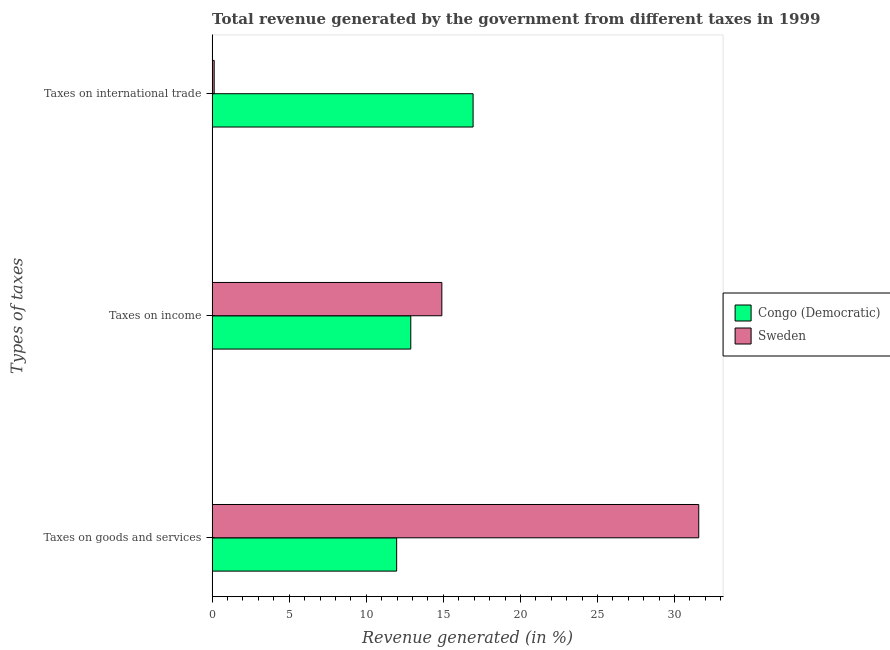How many groups of bars are there?
Provide a short and direct response. 3. Are the number of bars per tick equal to the number of legend labels?
Your answer should be compact. Yes. Are the number of bars on each tick of the Y-axis equal?
Provide a short and direct response. Yes. What is the label of the 3rd group of bars from the top?
Provide a short and direct response. Taxes on goods and services. What is the percentage of revenue generated by taxes on goods and services in Sweden?
Keep it short and to the point. 31.57. Across all countries, what is the maximum percentage of revenue generated by tax on international trade?
Provide a succinct answer. 16.93. Across all countries, what is the minimum percentage of revenue generated by taxes on income?
Your answer should be very brief. 12.89. In which country was the percentage of revenue generated by tax on international trade minimum?
Offer a terse response. Sweden. What is the total percentage of revenue generated by taxes on income in the graph?
Your response must be concise. 27.79. What is the difference between the percentage of revenue generated by taxes on goods and services in Sweden and that in Congo (Democratic)?
Keep it short and to the point. 19.6. What is the difference between the percentage of revenue generated by taxes on goods and services in Congo (Democratic) and the percentage of revenue generated by tax on international trade in Sweden?
Make the answer very short. 11.84. What is the average percentage of revenue generated by taxes on income per country?
Offer a terse response. 13.89. What is the difference between the percentage of revenue generated by taxes on goods and services and percentage of revenue generated by taxes on income in Congo (Democratic)?
Keep it short and to the point. -0.92. In how many countries, is the percentage of revenue generated by tax on international trade greater than 23 %?
Offer a terse response. 0. What is the ratio of the percentage of revenue generated by tax on international trade in Sweden to that in Congo (Democratic)?
Your answer should be compact. 0.01. Is the difference between the percentage of revenue generated by taxes on goods and services in Sweden and Congo (Democratic) greater than the difference between the percentage of revenue generated by taxes on income in Sweden and Congo (Democratic)?
Provide a succinct answer. Yes. What is the difference between the highest and the second highest percentage of revenue generated by tax on international trade?
Your response must be concise. 16.8. What is the difference between the highest and the lowest percentage of revenue generated by taxes on goods and services?
Offer a very short reply. 19.6. What does the 2nd bar from the top in Taxes on income represents?
Your answer should be very brief. Congo (Democratic). What does the 1st bar from the bottom in Taxes on international trade represents?
Your response must be concise. Congo (Democratic). How many bars are there?
Keep it short and to the point. 6. Are all the bars in the graph horizontal?
Make the answer very short. Yes. What is the difference between two consecutive major ticks on the X-axis?
Provide a succinct answer. 5. What is the title of the graph?
Make the answer very short. Total revenue generated by the government from different taxes in 1999. What is the label or title of the X-axis?
Offer a terse response. Revenue generated (in %). What is the label or title of the Y-axis?
Make the answer very short. Types of taxes. What is the Revenue generated (in %) of Congo (Democratic) in Taxes on goods and services?
Provide a succinct answer. 11.97. What is the Revenue generated (in %) in Sweden in Taxes on goods and services?
Provide a short and direct response. 31.57. What is the Revenue generated (in %) of Congo (Democratic) in Taxes on income?
Make the answer very short. 12.89. What is the Revenue generated (in %) of Sweden in Taxes on income?
Keep it short and to the point. 14.9. What is the Revenue generated (in %) in Congo (Democratic) in Taxes on international trade?
Provide a short and direct response. 16.93. What is the Revenue generated (in %) of Sweden in Taxes on international trade?
Provide a succinct answer. 0.13. Across all Types of taxes, what is the maximum Revenue generated (in %) of Congo (Democratic)?
Offer a terse response. 16.93. Across all Types of taxes, what is the maximum Revenue generated (in %) in Sweden?
Your answer should be compact. 31.57. Across all Types of taxes, what is the minimum Revenue generated (in %) in Congo (Democratic)?
Your response must be concise. 11.97. Across all Types of taxes, what is the minimum Revenue generated (in %) of Sweden?
Ensure brevity in your answer.  0.13. What is the total Revenue generated (in %) of Congo (Democratic) in the graph?
Your answer should be compact. 41.79. What is the total Revenue generated (in %) in Sweden in the graph?
Provide a succinct answer. 46.6. What is the difference between the Revenue generated (in %) in Congo (Democratic) in Taxes on goods and services and that in Taxes on income?
Your answer should be very brief. -0.92. What is the difference between the Revenue generated (in %) of Sweden in Taxes on goods and services and that in Taxes on income?
Your answer should be compact. 16.67. What is the difference between the Revenue generated (in %) in Congo (Democratic) in Taxes on goods and services and that in Taxes on international trade?
Offer a terse response. -4.96. What is the difference between the Revenue generated (in %) of Sweden in Taxes on goods and services and that in Taxes on international trade?
Make the answer very short. 31.43. What is the difference between the Revenue generated (in %) in Congo (Democratic) in Taxes on income and that in Taxes on international trade?
Offer a terse response. -4.04. What is the difference between the Revenue generated (in %) in Sweden in Taxes on income and that in Taxes on international trade?
Your answer should be compact. 14.77. What is the difference between the Revenue generated (in %) of Congo (Democratic) in Taxes on goods and services and the Revenue generated (in %) of Sweden in Taxes on income?
Give a very brief answer. -2.93. What is the difference between the Revenue generated (in %) in Congo (Democratic) in Taxes on goods and services and the Revenue generated (in %) in Sweden in Taxes on international trade?
Your response must be concise. 11.84. What is the difference between the Revenue generated (in %) of Congo (Democratic) in Taxes on income and the Revenue generated (in %) of Sweden in Taxes on international trade?
Keep it short and to the point. 12.75. What is the average Revenue generated (in %) of Congo (Democratic) per Types of taxes?
Make the answer very short. 13.93. What is the average Revenue generated (in %) in Sweden per Types of taxes?
Provide a succinct answer. 15.53. What is the difference between the Revenue generated (in %) in Congo (Democratic) and Revenue generated (in %) in Sweden in Taxes on goods and services?
Your answer should be compact. -19.6. What is the difference between the Revenue generated (in %) in Congo (Democratic) and Revenue generated (in %) in Sweden in Taxes on income?
Your response must be concise. -2.02. What is the difference between the Revenue generated (in %) of Congo (Democratic) and Revenue generated (in %) of Sweden in Taxes on international trade?
Your answer should be compact. 16.8. What is the ratio of the Revenue generated (in %) of Congo (Democratic) in Taxes on goods and services to that in Taxes on income?
Your response must be concise. 0.93. What is the ratio of the Revenue generated (in %) of Sweden in Taxes on goods and services to that in Taxes on income?
Provide a short and direct response. 2.12. What is the ratio of the Revenue generated (in %) in Congo (Democratic) in Taxes on goods and services to that in Taxes on international trade?
Ensure brevity in your answer.  0.71. What is the ratio of the Revenue generated (in %) of Sweden in Taxes on goods and services to that in Taxes on international trade?
Your answer should be compact. 235.23. What is the ratio of the Revenue generated (in %) of Congo (Democratic) in Taxes on income to that in Taxes on international trade?
Offer a very short reply. 0.76. What is the ratio of the Revenue generated (in %) in Sweden in Taxes on income to that in Taxes on international trade?
Make the answer very short. 111.04. What is the difference between the highest and the second highest Revenue generated (in %) of Congo (Democratic)?
Your response must be concise. 4.04. What is the difference between the highest and the second highest Revenue generated (in %) of Sweden?
Your answer should be very brief. 16.67. What is the difference between the highest and the lowest Revenue generated (in %) in Congo (Democratic)?
Keep it short and to the point. 4.96. What is the difference between the highest and the lowest Revenue generated (in %) of Sweden?
Ensure brevity in your answer.  31.43. 